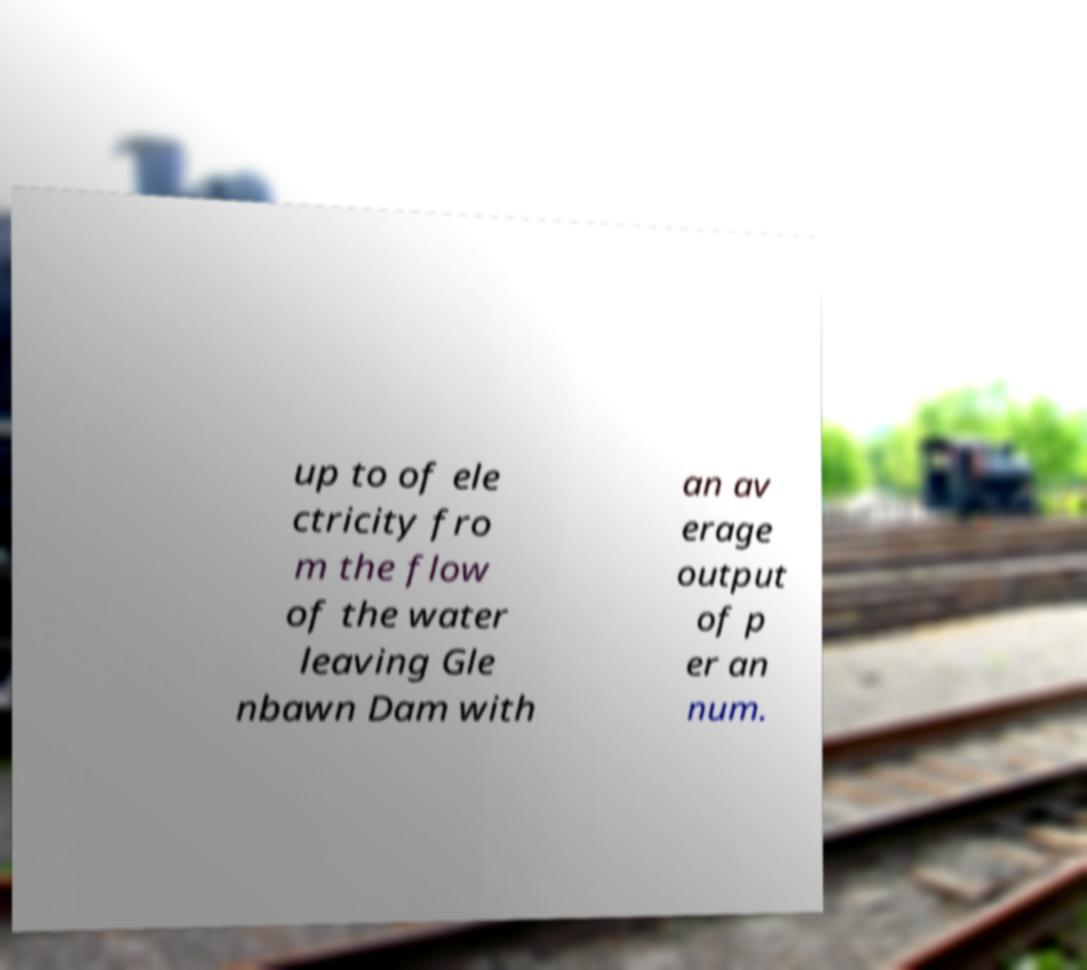Could you extract and type out the text from this image? up to of ele ctricity fro m the flow of the water leaving Gle nbawn Dam with an av erage output of p er an num. 